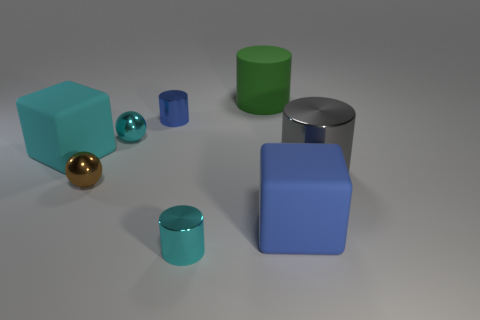What is the big cube that is on the right side of the cylinder that is in front of the blue matte object made of?
Provide a succinct answer. Rubber. Are the block that is in front of the large gray cylinder and the big gray object made of the same material?
Offer a very short reply. No. Is the shape of the cyan metallic object in front of the small brown metallic sphere the same as the cyan shiny thing that is behind the big blue matte thing?
Offer a terse response. No. Is there a small brown thing made of the same material as the small cyan cylinder?
Your response must be concise. Yes. How many red objects are either cubes or large objects?
Make the answer very short. 0. There is a shiny object that is both behind the big cyan thing and right of the cyan metal sphere; what size is it?
Ensure brevity in your answer.  Small. Are there more shiny spheres behind the small cyan shiny cylinder than blue objects?
Make the answer very short. No. How many blocks are tiny shiny objects or big things?
Provide a short and direct response. 2. There is a matte thing that is both to the right of the tiny cyan sphere and in front of the big green matte cylinder; what is its shape?
Make the answer very short. Cube. Are there the same number of tiny metallic things that are left of the cyan sphere and tiny cyan things behind the gray cylinder?
Give a very brief answer. Yes. 